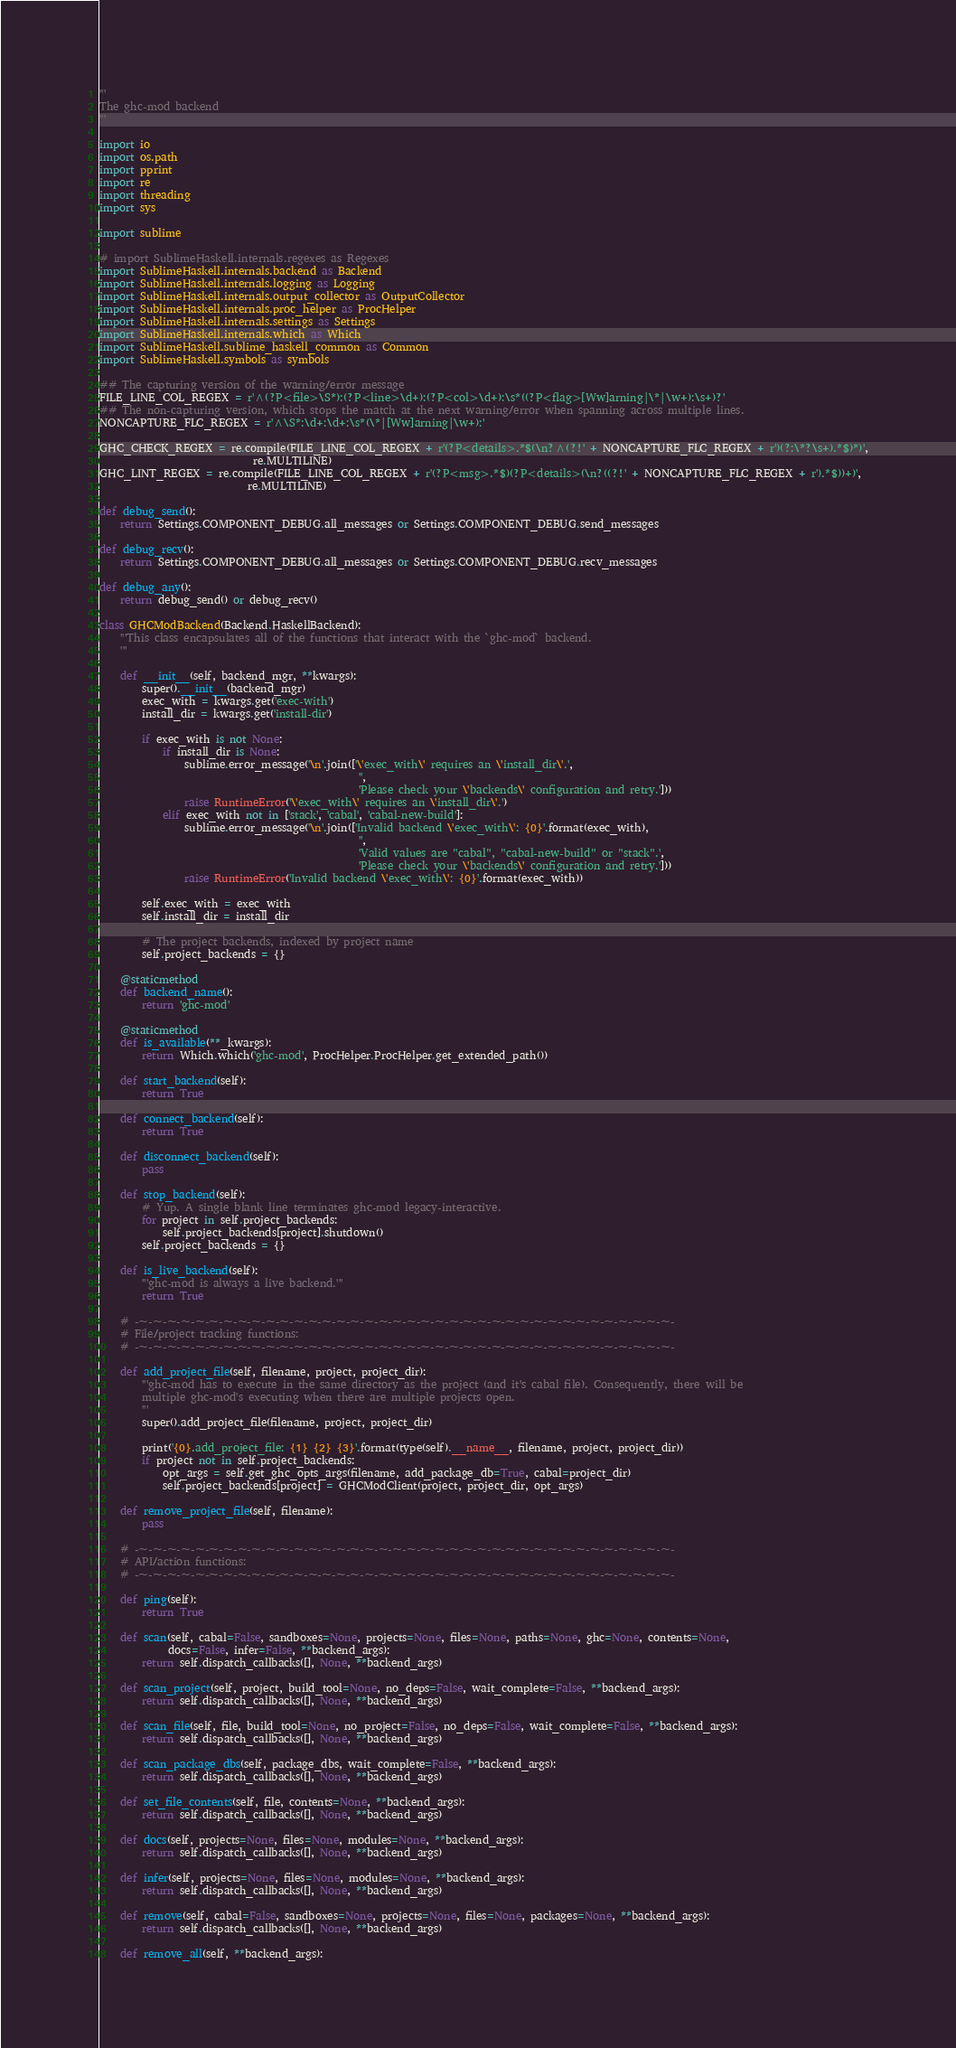<code> <loc_0><loc_0><loc_500><loc_500><_Python_>'''
The ghc-mod backend
'''

import io
import os.path
import pprint
import re
import threading
import sys

import sublime

# import SublimeHaskell.internals.regexes as Regexes
import SublimeHaskell.internals.backend as Backend
import SublimeHaskell.internals.logging as Logging
import SublimeHaskell.internals.output_collector as OutputCollector
import SublimeHaskell.internals.proc_helper as ProcHelper
import SublimeHaskell.internals.settings as Settings
import SublimeHaskell.internals.which as Which
import SublimeHaskell.sublime_haskell_common as Common
import SublimeHaskell.symbols as symbols

## The capturing version of the warning/error message
FILE_LINE_COL_REGEX = r'^(?P<file>\S*):(?P<line>\d+):(?P<col>\d+):\s*((?P<flag>[Ww]arning|\*|\w+):\s+)?'
## The non-capturing version, which stops the match at the next warning/error when spanning across multiple lines.
NONCAPTURE_FLC_REGEX = r'^\S*:\d+:\d+:\s*(\*|[Ww]arning|\w+):'

GHC_CHECK_REGEX = re.compile(FILE_LINE_COL_REGEX + r'(?P<details>.*$(\n?^(?!' + NONCAPTURE_FLC_REGEX + r')(?:\*?\s+).*$)*)',
                             re.MULTILINE)
GHC_LINT_REGEX = re.compile(FILE_LINE_COL_REGEX + r'(?P<msg>.*$)(?P<details>(\n?((?!' + NONCAPTURE_FLC_REGEX + r').*$))+)',
                            re.MULTILINE)

def debug_send():
    return Settings.COMPONENT_DEBUG.all_messages or Settings.COMPONENT_DEBUG.send_messages

def debug_recv():
    return Settings.COMPONENT_DEBUG.all_messages or Settings.COMPONENT_DEBUG.recv_messages

def debug_any():
    return debug_send() or debug_recv()

class GHCModBackend(Backend.HaskellBackend):
    '''This class encapsulates all of the functions that interact with the `ghc-mod` backend.
    '''

    def __init__(self, backend_mgr, **kwargs):
        super().__init__(backend_mgr)
        exec_with = kwargs.get('exec-with')
        install_dir = kwargs.get('install-dir')

        if exec_with is not None:
            if install_dir is None:
                sublime.error_message('\n'.join(['\'exec_with\' requires an \'install_dir\'.',
                                                 '',
                                                 'Please check your \'backends\' configuration and retry.']))
                raise RuntimeError('\'exec_with\' requires an \'install_dir\'.')
            elif exec_with not in ['stack', 'cabal', 'cabal-new-build']:
                sublime.error_message('\n'.join(['Invalid backend \'exec_with\': {0}'.format(exec_with),
                                                 '',
                                                 'Valid values are "cabal", "cabal-new-build" or "stack".',
                                                 'Please check your \'backends\' configuration and retry.']))
                raise RuntimeError('Invalid backend \'exec_with\': {0}'.format(exec_with))

        self.exec_with = exec_with
        self.install_dir = install_dir

        # The project backends, indexed by project name
        self.project_backends = {}

    @staticmethod
    def backend_name():
        return 'ghc-mod'

    @staticmethod
    def is_available(**_kwargs):
        return Which.which('ghc-mod', ProcHelper.ProcHelper.get_extended_path())

    def start_backend(self):
        return True

    def connect_backend(self):
        return True

    def disconnect_backend(self):
        pass

    def stop_backend(self):
        # Yup. A single blank line terminates ghc-mod legacy-interactive.
        for project in self.project_backends:
            self.project_backends[project].shutdown()
        self.project_backends = {}

    def is_live_backend(self):
        '''ghc-mod is always a live backend.'''
        return True

    # -~-~-~-~-~-~-~-~-~-~-~-~-~-~-~-~-~-~-~-~-~-~-~-~-~-~-~-~-~-~-~-~-~-~-~-~-~-~-
    # File/project tracking functions:
    # -~-~-~-~-~-~-~-~-~-~-~-~-~-~-~-~-~-~-~-~-~-~-~-~-~-~-~-~-~-~-~-~-~-~-~-~-~-~-

    def add_project_file(self, filename, project, project_dir):
        '''ghc-mod has to execute in the same directory as the project (and it's cabal file). Consequently, there will be
        multiple ghc-mod's executing when there are multiple projects open.
        '''
        super().add_project_file(filename, project, project_dir)

        print('{0}.add_project_file: {1} {2} {3}'.format(type(self).__name__, filename, project, project_dir))
        if project not in self.project_backends:
            opt_args = self.get_ghc_opts_args(filename, add_package_db=True, cabal=project_dir)
            self.project_backends[project] = GHCModClient(project, project_dir, opt_args)

    def remove_project_file(self, filename):
        pass

    # -~-~-~-~-~-~-~-~-~-~-~-~-~-~-~-~-~-~-~-~-~-~-~-~-~-~-~-~-~-~-~-~-~-~-~-~-~-~-
    # API/action functions:
    # -~-~-~-~-~-~-~-~-~-~-~-~-~-~-~-~-~-~-~-~-~-~-~-~-~-~-~-~-~-~-~-~-~-~-~-~-~-~-

    def ping(self):
        return True

    def scan(self, cabal=False, sandboxes=None, projects=None, files=None, paths=None, ghc=None, contents=None,
             docs=False, infer=False, **backend_args):
        return self.dispatch_callbacks([], None, **backend_args)

    def scan_project(self, project, build_tool=None, no_deps=False, wait_complete=False, **backend_args):
        return self.dispatch_callbacks([], None, **backend_args)

    def scan_file(self, file, build_tool=None, no_project=False, no_deps=False, wait_complete=False, **backend_args):
        return self.dispatch_callbacks([], None, **backend_args)

    def scan_package_dbs(self, package_dbs, wait_complete=False, **backend_args):
        return self.dispatch_callbacks([], None, **backend_args)

    def set_file_contents(self, file, contents=None, **backend_args):
        return self.dispatch_callbacks([], None, **backend_args)

    def docs(self, projects=None, files=None, modules=None, **backend_args):
        return self.dispatch_callbacks([], None, **backend_args)

    def infer(self, projects=None, files=None, modules=None, **backend_args):
        return self.dispatch_callbacks([], None, **backend_args)

    def remove(self, cabal=False, sandboxes=None, projects=None, files=None, packages=None, **backend_args):
        return self.dispatch_callbacks([], None, **backend_args)

    def remove_all(self, **backend_args):</code> 